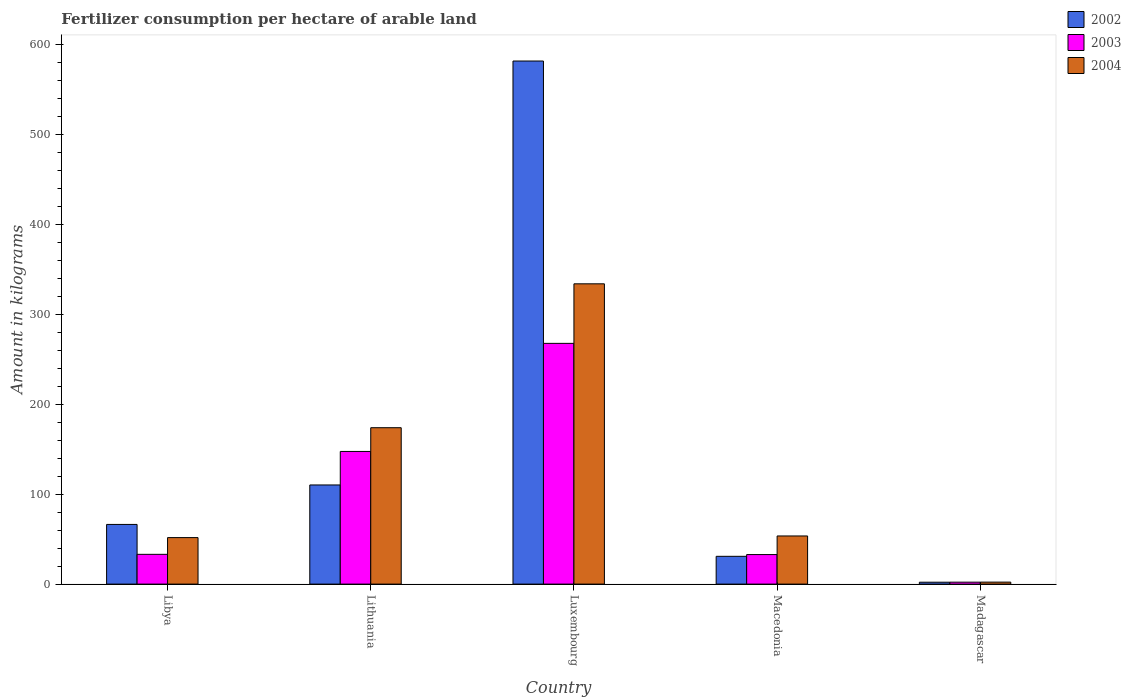How many different coloured bars are there?
Offer a very short reply. 3. How many groups of bars are there?
Offer a very short reply. 5. Are the number of bars per tick equal to the number of legend labels?
Make the answer very short. Yes. Are the number of bars on each tick of the X-axis equal?
Offer a terse response. Yes. How many bars are there on the 5th tick from the left?
Ensure brevity in your answer.  3. How many bars are there on the 5th tick from the right?
Ensure brevity in your answer.  3. What is the label of the 1st group of bars from the left?
Your answer should be compact. Libya. What is the amount of fertilizer consumption in 2002 in Luxembourg?
Ensure brevity in your answer.  581.15. Across all countries, what is the maximum amount of fertilizer consumption in 2002?
Offer a very short reply. 581.15. Across all countries, what is the minimum amount of fertilizer consumption in 2002?
Keep it short and to the point. 2.09. In which country was the amount of fertilizer consumption in 2002 maximum?
Your response must be concise. Luxembourg. In which country was the amount of fertilizer consumption in 2003 minimum?
Keep it short and to the point. Madagascar. What is the total amount of fertilizer consumption in 2003 in the graph?
Provide a short and direct response. 482.87. What is the difference between the amount of fertilizer consumption in 2002 in Libya and that in Luxembourg?
Your answer should be very brief. -514.85. What is the difference between the amount of fertilizer consumption in 2004 in Lithuania and the amount of fertilizer consumption in 2002 in Macedonia?
Your answer should be very brief. 142.9. What is the average amount of fertilizer consumption in 2004 per country?
Your response must be concise. 122.94. What is the difference between the amount of fertilizer consumption of/in 2004 and amount of fertilizer consumption of/in 2002 in Lithuania?
Your answer should be very brief. 63.61. What is the ratio of the amount of fertilizer consumption in 2003 in Libya to that in Madagascar?
Offer a very short reply. 15.39. Is the difference between the amount of fertilizer consumption in 2004 in Libya and Luxembourg greater than the difference between the amount of fertilizer consumption in 2002 in Libya and Luxembourg?
Offer a terse response. Yes. What is the difference between the highest and the second highest amount of fertilizer consumption in 2003?
Provide a short and direct response. -234.4. What is the difference between the highest and the lowest amount of fertilizer consumption in 2004?
Provide a short and direct response. 331.41. In how many countries, is the amount of fertilizer consumption in 2003 greater than the average amount of fertilizer consumption in 2003 taken over all countries?
Offer a terse response. 2. Is the sum of the amount of fertilizer consumption in 2003 in Libya and Macedonia greater than the maximum amount of fertilizer consumption in 2004 across all countries?
Make the answer very short. No. What does the 2nd bar from the right in Luxembourg represents?
Ensure brevity in your answer.  2003. How many bars are there?
Offer a very short reply. 15. Are all the bars in the graph horizontal?
Give a very brief answer. No. How many countries are there in the graph?
Offer a terse response. 5. What is the difference between two consecutive major ticks on the Y-axis?
Offer a very short reply. 100. Does the graph contain any zero values?
Offer a very short reply. No. What is the title of the graph?
Ensure brevity in your answer.  Fertilizer consumption per hectare of arable land. What is the label or title of the Y-axis?
Make the answer very short. Amount in kilograms. What is the Amount in kilograms of 2002 in Libya?
Make the answer very short. 66.29. What is the Amount in kilograms of 2003 in Libya?
Your response must be concise. 33.07. What is the Amount in kilograms of 2004 in Libya?
Offer a terse response. 51.66. What is the Amount in kilograms in 2002 in Lithuania?
Your response must be concise. 110.15. What is the Amount in kilograms of 2003 in Lithuania?
Offer a terse response. 147.38. What is the Amount in kilograms of 2004 in Lithuania?
Provide a succinct answer. 173.76. What is the Amount in kilograms of 2002 in Luxembourg?
Offer a very short reply. 581.15. What is the Amount in kilograms of 2003 in Luxembourg?
Give a very brief answer. 267.47. What is the Amount in kilograms of 2004 in Luxembourg?
Make the answer very short. 333.61. What is the Amount in kilograms in 2002 in Macedonia?
Keep it short and to the point. 30.86. What is the Amount in kilograms of 2003 in Macedonia?
Keep it short and to the point. 32.8. What is the Amount in kilograms in 2004 in Macedonia?
Provide a short and direct response. 53.48. What is the Amount in kilograms of 2002 in Madagascar?
Provide a succinct answer. 2.09. What is the Amount in kilograms of 2003 in Madagascar?
Your response must be concise. 2.15. What is the Amount in kilograms in 2004 in Madagascar?
Give a very brief answer. 2.2. Across all countries, what is the maximum Amount in kilograms in 2002?
Provide a succinct answer. 581.15. Across all countries, what is the maximum Amount in kilograms of 2003?
Provide a short and direct response. 267.47. Across all countries, what is the maximum Amount in kilograms in 2004?
Your answer should be very brief. 333.61. Across all countries, what is the minimum Amount in kilograms of 2002?
Ensure brevity in your answer.  2.09. Across all countries, what is the minimum Amount in kilograms of 2003?
Give a very brief answer. 2.15. Across all countries, what is the minimum Amount in kilograms in 2004?
Make the answer very short. 2.2. What is the total Amount in kilograms of 2002 in the graph?
Provide a short and direct response. 790.55. What is the total Amount in kilograms in 2003 in the graph?
Give a very brief answer. 482.87. What is the total Amount in kilograms of 2004 in the graph?
Ensure brevity in your answer.  614.71. What is the difference between the Amount in kilograms of 2002 in Libya and that in Lithuania?
Provide a succinct answer. -43.86. What is the difference between the Amount in kilograms in 2003 in Libya and that in Lithuania?
Ensure brevity in your answer.  -114.31. What is the difference between the Amount in kilograms in 2004 in Libya and that in Lithuania?
Provide a succinct answer. -122.1. What is the difference between the Amount in kilograms of 2002 in Libya and that in Luxembourg?
Your response must be concise. -514.85. What is the difference between the Amount in kilograms in 2003 in Libya and that in Luxembourg?
Give a very brief answer. -234.4. What is the difference between the Amount in kilograms in 2004 in Libya and that in Luxembourg?
Your response must be concise. -281.96. What is the difference between the Amount in kilograms in 2002 in Libya and that in Macedonia?
Make the answer very short. 35.43. What is the difference between the Amount in kilograms in 2003 in Libya and that in Macedonia?
Offer a very short reply. 0.27. What is the difference between the Amount in kilograms in 2004 in Libya and that in Macedonia?
Give a very brief answer. -1.82. What is the difference between the Amount in kilograms in 2002 in Libya and that in Madagascar?
Your response must be concise. 64.2. What is the difference between the Amount in kilograms of 2003 in Libya and that in Madagascar?
Your answer should be compact. 30.92. What is the difference between the Amount in kilograms in 2004 in Libya and that in Madagascar?
Offer a very short reply. 49.45. What is the difference between the Amount in kilograms of 2002 in Lithuania and that in Luxembourg?
Give a very brief answer. -470.99. What is the difference between the Amount in kilograms in 2003 in Lithuania and that in Luxembourg?
Your response must be concise. -120.08. What is the difference between the Amount in kilograms in 2004 in Lithuania and that in Luxembourg?
Your answer should be compact. -159.85. What is the difference between the Amount in kilograms in 2002 in Lithuania and that in Macedonia?
Offer a terse response. 79.3. What is the difference between the Amount in kilograms in 2003 in Lithuania and that in Macedonia?
Make the answer very short. 114.58. What is the difference between the Amount in kilograms of 2004 in Lithuania and that in Macedonia?
Provide a short and direct response. 120.28. What is the difference between the Amount in kilograms in 2002 in Lithuania and that in Madagascar?
Ensure brevity in your answer.  108.06. What is the difference between the Amount in kilograms in 2003 in Lithuania and that in Madagascar?
Give a very brief answer. 145.24. What is the difference between the Amount in kilograms of 2004 in Lithuania and that in Madagascar?
Your answer should be compact. 171.56. What is the difference between the Amount in kilograms in 2002 in Luxembourg and that in Macedonia?
Provide a short and direct response. 550.29. What is the difference between the Amount in kilograms in 2003 in Luxembourg and that in Macedonia?
Give a very brief answer. 234.66. What is the difference between the Amount in kilograms of 2004 in Luxembourg and that in Macedonia?
Ensure brevity in your answer.  280.13. What is the difference between the Amount in kilograms of 2002 in Luxembourg and that in Madagascar?
Your answer should be compact. 579.05. What is the difference between the Amount in kilograms in 2003 in Luxembourg and that in Madagascar?
Provide a succinct answer. 265.32. What is the difference between the Amount in kilograms in 2004 in Luxembourg and that in Madagascar?
Offer a very short reply. 331.41. What is the difference between the Amount in kilograms in 2002 in Macedonia and that in Madagascar?
Make the answer very short. 28.77. What is the difference between the Amount in kilograms in 2003 in Macedonia and that in Madagascar?
Your answer should be compact. 30.66. What is the difference between the Amount in kilograms in 2004 in Macedonia and that in Madagascar?
Your answer should be very brief. 51.28. What is the difference between the Amount in kilograms of 2002 in Libya and the Amount in kilograms of 2003 in Lithuania?
Your answer should be very brief. -81.09. What is the difference between the Amount in kilograms in 2002 in Libya and the Amount in kilograms in 2004 in Lithuania?
Your answer should be compact. -107.47. What is the difference between the Amount in kilograms in 2003 in Libya and the Amount in kilograms in 2004 in Lithuania?
Your answer should be very brief. -140.69. What is the difference between the Amount in kilograms in 2002 in Libya and the Amount in kilograms in 2003 in Luxembourg?
Ensure brevity in your answer.  -201.18. What is the difference between the Amount in kilograms in 2002 in Libya and the Amount in kilograms in 2004 in Luxembourg?
Your response must be concise. -267.32. What is the difference between the Amount in kilograms of 2003 in Libya and the Amount in kilograms of 2004 in Luxembourg?
Your answer should be very brief. -300.54. What is the difference between the Amount in kilograms in 2002 in Libya and the Amount in kilograms in 2003 in Macedonia?
Offer a very short reply. 33.49. What is the difference between the Amount in kilograms of 2002 in Libya and the Amount in kilograms of 2004 in Macedonia?
Ensure brevity in your answer.  12.81. What is the difference between the Amount in kilograms in 2003 in Libya and the Amount in kilograms in 2004 in Macedonia?
Keep it short and to the point. -20.41. What is the difference between the Amount in kilograms of 2002 in Libya and the Amount in kilograms of 2003 in Madagascar?
Provide a succinct answer. 64.14. What is the difference between the Amount in kilograms in 2002 in Libya and the Amount in kilograms in 2004 in Madagascar?
Your response must be concise. 64.09. What is the difference between the Amount in kilograms of 2003 in Libya and the Amount in kilograms of 2004 in Madagascar?
Your response must be concise. 30.87. What is the difference between the Amount in kilograms in 2002 in Lithuania and the Amount in kilograms in 2003 in Luxembourg?
Make the answer very short. -157.31. What is the difference between the Amount in kilograms in 2002 in Lithuania and the Amount in kilograms in 2004 in Luxembourg?
Your answer should be compact. -223.46. What is the difference between the Amount in kilograms of 2003 in Lithuania and the Amount in kilograms of 2004 in Luxembourg?
Keep it short and to the point. -186.23. What is the difference between the Amount in kilograms in 2002 in Lithuania and the Amount in kilograms in 2003 in Macedonia?
Offer a terse response. 77.35. What is the difference between the Amount in kilograms of 2002 in Lithuania and the Amount in kilograms of 2004 in Macedonia?
Offer a terse response. 56.67. What is the difference between the Amount in kilograms in 2003 in Lithuania and the Amount in kilograms in 2004 in Macedonia?
Make the answer very short. 93.9. What is the difference between the Amount in kilograms in 2002 in Lithuania and the Amount in kilograms in 2003 in Madagascar?
Your answer should be very brief. 108.01. What is the difference between the Amount in kilograms of 2002 in Lithuania and the Amount in kilograms of 2004 in Madagascar?
Your answer should be very brief. 107.95. What is the difference between the Amount in kilograms in 2003 in Lithuania and the Amount in kilograms in 2004 in Madagascar?
Keep it short and to the point. 145.18. What is the difference between the Amount in kilograms in 2002 in Luxembourg and the Amount in kilograms in 2003 in Macedonia?
Provide a succinct answer. 548.34. What is the difference between the Amount in kilograms in 2002 in Luxembourg and the Amount in kilograms in 2004 in Macedonia?
Ensure brevity in your answer.  527.66. What is the difference between the Amount in kilograms of 2003 in Luxembourg and the Amount in kilograms of 2004 in Macedonia?
Your answer should be compact. 213.99. What is the difference between the Amount in kilograms in 2002 in Luxembourg and the Amount in kilograms in 2003 in Madagascar?
Your answer should be compact. 579. What is the difference between the Amount in kilograms in 2002 in Luxembourg and the Amount in kilograms in 2004 in Madagascar?
Make the answer very short. 578.94. What is the difference between the Amount in kilograms of 2003 in Luxembourg and the Amount in kilograms of 2004 in Madagascar?
Your answer should be compact. 265.26. What is the difference between the Amount in kilograms of 2002 in Macedonia and the Amount in kilograms of 2003 in Madagascar?
Your response must be concise. 28.71. What is the difference between the Amount in kilograms of 2002 in Macedonia and the Amount in kilograms of 2004 in Madagascar?
Ensure brevity in your answer.  28.66. What is the difference between the Amount in kilograms in 2003 in Macedonia and the Amount in kilograms in 2004 in Madagascar?
Your answer should be compact. 30.6. What is the average Amount in kilograms of 2002 per country?
Offer a very short reply. 158.11. What is the average Amount in kilograms in 2003 per country?
Provide a short and direct response. 96.58. What is the average Amount in kilograms in 2004 per country?
Your answer should be very brief. 122.94. What is the difference between the Amount in kilograms of 2002 and Amount in kilograms of 2003 in Libya?
Your response must be concise. 33.22. What is the difference between the Amount in kilograms in 2002 and Amount in kilograms in 2004 in Libya?
Provide a short and direct response. 14.64. What is the difference between the Amount in kilograms in 2003 and Amount in kilograms in 2004 in Libya?
Provide a short and direct response. -18.59. What is the difference between the Amount in kilograms in 2002 and Amount in kilograms in 2003 in Lithuania?
Offer a very short reply. -37.23. What is the difference between the Amount in kilograms of 2002 and Amount in kilograms of 2004 in Lithuania?
Offer a very short reply. -63.61. What is the difference between the Amount in kilograms of 2003 and Amount in kilograms of 2004 in Lithuania?
Your response must be concise. -26.38. What is the difference between the Amount in kilograms of 2002 and Amount in kilograms of 2003 in Luxembourg?
Offer a very short reply. 313.68. What is the difference between the Amount in kilograms in 2002 and Amount in kilograms in 2004 in Luxembourg?
Your answer should be very brief. 247.53. What is the difference between the Amount in kilograms of 2003 and Amount in kilograms of 2004 in Luxembourg?
Provide a short and direct response. -66.15. What is the difference between the Amount in kilograms of 2002 and Amount in kilograms of 2003 in Macedonia?
Your answer should be very brief. -1.95. What is the difference between the Amount in kilograms of 2002 and Amount in kilograms of 2004 in Macedonia?
Your answer should be compact. -22.62. What is the difference between the Amount in kilograms of 2003 and Amount in kilograms of 2004 in Macedonia?
Ensure brevity in your answer.  -20.68. What is the difference between the Amount in kilograms in 2002 and Amount in kilograms in 2003 in Madagascar?
Your answer should be very brief. -0.05. What is the difference between the Amount in kilograms in 2002 and Amount in kilograms in 2004 in Madagascar?
Your answer should be very brief. -0.11. What is the difference between the Amount in kilograms in 2003 and Amount in kilograms in 2004 in Madagascar?
Your answer should be very brief. -0.05. What is the ratio of the Amount in kilograms of 2002 in Libya to that in Lithuania?
Provide a short and direct response. 0.6. What is the ratio of the Amount in kilograms of 2003 in Libya to that in Lithuania?
Give a very brief answer. 0.22. What is the ratio of the Amount in kilograms in 2004 in Libya to that in Lithuania?
Your answer should be compact. 0.3. What is the ratio of the Amount in kilograms of 2002 in Libya to that in Luxembourg?
Provide a succinct answer. 0.11. What is the ratio of the Amount in kilograms in 2003 in Libya to that in Luxembourg?
Provide a succinct answer. 0.12. What is the ratio of the Amount in kilograms in 2004 in Libya to that in Luxembourg?
Offer a very short reply. 0.15. What is the ratio of the Amount in kilograms of 2002 in Libya to that in Macedonia?
Give a very brief answer. 2.15. What is the ratio of the Amount in kilograms in 2003 in Libya to that in Macedonia?
Your answer should be very brief. 1.01. What is the ratio of the Amount in kilograms of 2004 in Libya to that in Macedonia?
Make the answer very short. 0.97. What is the ratio of the Amount in kilograms in 2002 in Libya to that in Madagascar?
Ensure brevity in your answer.  31.65. What is the ratio of the Amount in kilograms in 2003 in Libya to that in Madagascar?
Provide a succinct answer. 15.39. What is the ratio of the Amount in kilograms of 2004 in Libya to that in Madagascar?
Offer a very short reply. 23.45. What is the ratio of the Amount in kilograms of 2002 in Lithuania to that in Luxembourg?
Give a very brief answer. 0.19. What is the ratio of the Amount in kilograms of 2003 in Lithuania to that in Luxembourg?
Provide a succinct answer. 0.55. What is the ratio of the Amount in kilograms in 2004 in Lithuania to that in Luxembourg?
Give a very brief answer. 0.52. What is the ratio of the Amount in kilograms of 2002 in Lithuania to that in Macedonia?
Provide a short and direct response. 3.57. What is the ratio of the Amount in kilograms of 2003 in Lithuania to that in Macedonia?
Keep it short and to the point. 4.49. What is the ratio of the Amount in kilograms in 2004 in Lithuania to that in Macedonia?
Your response must be concise. 3.25. What is the ratio of the Amount in kilograms in 2002 in Lithuania to that in Madagascar?
Make the answer very short. 52.6. What is the ratio of the Amount in kilograms in 2003 in Lithuania to that in Madagascar?
Provide a succinct answer. 68.61. What is the ratio of the Amount in kilograms in 2004 in Lithuania to that in Madagascar?
Provide a succinct answer. 78.87. What is the ratio of the Amount in kilograms of 2002 in Luxembourg to that in Macedonia?
Give a very brief answer. 18.83. What is the ratio of the Amount in kilograms in 2003 in Luxembourg to that in Macedonia?
Keep it short and to the point. 8.15. What is the ratio of the Amount in kilograms in 2004 in Luxembourg to that in Macedonia?
Your response must be concise. 6.24. What is the ratio of the Amount in kilograms of 2002 in Luxembourg to that in Madagascar?
Keep it short and to the point. 277.5. What is the ratio of the Amount in kilograms of 2003 in Luxembourg to that in Madagascar?
Provide a succinct answer. 124.51. What is the ratio of the Amount in kilograms of 2004 in Luxembourg to that in Madagascar?
Offer a terse response. 151.43. What is the ratio of the Amount in kilograms of 2002 in Macedonia to that in Madagascar?
Provide a succinct answer. 14.74. What is the ratio of the Amount in kilograms of 2003 in Macedonia to that in Madagascar?
Make the answer very short. 15.27. What is the ratio of the Amount in kilograms of 2004 in Macedonia to that in Madagascar?
Make the answer very short. 24.28. What is the difference between the highest and the second highest Amount in kilograms of 2002?
Ensure brevity in your answer.  470.99. What is the difference between the highest and the second highest Amount in kilograms of 2003?
Provide a succinct answer. 120.08. What is the difference between the highest and the second highest Amount in kilograms in 2004?
Give a very brief answer. 159.85. What is the difference between the highest and the lowest Amount in kilograms in 2002?
Offer a terse response. 579.05. What is the difference between the highest and the lowest Amount in kilograms of 2003?
Provide a succinct answer. 265.32. What is the difference between the highest and the lowest Amount in kilograms in 2004?
Ensure brevity in your answer.  331.41. 